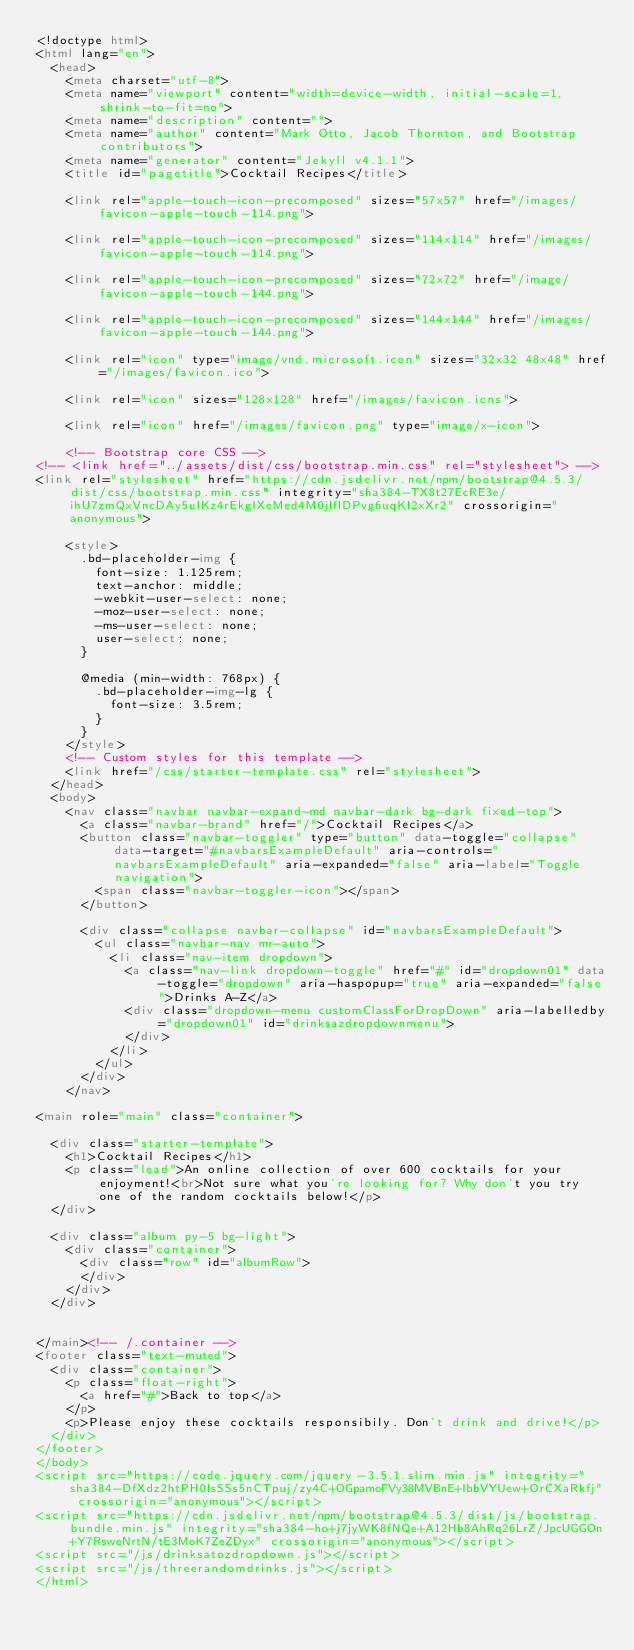<code> <loc_0><loc_0><loc_500><loc_500><_HTML_><!doctype html>
<html lang="en">
  <head>
    <meta charset="utf-8">
    <meta name="viewport" content="width=device-width, initial-scale=1, shrink-to-fit=no">
    <meta name="description" content="">
    <meta name="author" content="Mark Otto, Jacob Thornton, and Bootstrap contributors">
    <meta name="generator" content="Jekyll v4.1.1">
    <title id="pagetitle">Cocktail Recipes</title>
    
    <link rel="apple-touch-icon-precomposed" sizes="57x57" href="/images/favicon-apple-touch-114.png">

    <link rel="apple-touch-icon-precomposed" sizes="114x114" href="/images/favicon-apple-touch-114.png">

    <link rel="apple-touch-icon-precomposed" sizes="72x72" href="/image/favicon-apple-touch-144.png">

    <link rel="apple-touch-icon-precomposed" sizes="144x144" href="/images/favicon-apple-touch-144.png">

    <link rel="icon" type="image/vnd.microsoft.icon" sizes="32x32 48x48" href="/images/favicon.ico">

    <link rel="icon" sizes="128x128" href="/images/favicon.icns">

    <link rel="icon" href="/images/favicon.png" type="image/x-icon">

    <!-- Bootstrap core CSS -->
<!-- <link href="../assets/dist/css/bootstrap.min.css" rel="stylesheet"> -->
<link rel="stylesheet" href="https://cdn.jsdelivr.net/npm/bootstrap@4.5.3/dist/css/bootstrap.min.css" integrity="sha384-TX8t27EcRE3e/ihU7zmQxVncDAy5uIKz4rEkgIXeMed4M0jlfIDPvg6uqKI2xXr2" crossorigin="anonymous">

    <style>
      .bd-placeholder-img {
        font-size: 1.125rem;
        text-anchor: middle;
        -webkit-user-select: none;
        -moz-user-select: none;
        -ms-user-select: none;
        user-select: none;
      }

      @media (min-width: 768px) {
        .bd-placeholder-img-lg {
          font-size: 3.5rem;
        }
      }
    </style>
    <!-- Custom styles for this template -->
    <link href="/css/starter-template.css" rel="stylesheet">
  </head>
  <body>
    <nav class="navbar navbar-expand-md navbar-dark bg-dark fixed-top">
      <a class="navbar-brand" href="/">Cocktail Recipes</a>
      <button class="navbar-toggler" type="button" data-toggle="collapse" data-target="#navbarsExampleDefault" aria-controls="navbarsExampleDefault" aria-expanded="false" aria-label="Toggle navigation">
        <span class="navbar-toggler-icon"></span>
      </button>

      <div class="collapse navbar-collapse" id="navbarsExampleDefault">
        <ul class="navbar-nav mr-auto">
          <li class="nav-item dropdown">
            <a class="nav-link dropdown-toggle" href="#" id="dropdown01" data-toggle="dropdown" aria-haspopup="true" aria-expanded="false">Drinks A-Z</a>
            <div class="dropdown-menu customClassForDropDown" aria-labelledby="dropdown01" id="drinksazdropdownmenu">
            </div>
          </li>
        </ul>
      </div>
    </nav>

<main role="main" class="container">

  <div class="starter-template">
    <h1>Cocktail Recipes</h1>
    <p class="lead">An online collection of over 600 cocktails for your enjoyment!<br>Not sure what you're looking for? Why don't you try one of the random cocktails below!</p>
  </div>

  <div class="album py-5 bg-light">
    <div class="container">
      <div class="row" id="albumRow">
      </div>
    </div>
  </div>
  

</main><!-- /.container -->
<footer class="text-muted">
  <div class="container">
    <p class="float-right">
      <a href="#">Back to top</a>
    </p>
    <p>Please enjoy these cocktails responsibily. Don't drink and drive!</p>
  </div>
</footer>
</body>
<script src="https://code.jquery.com/jquery-3.5.1.slim.min.js" integrity="sha384-DfXdz2htPH0lsSSs5nCTpuj/zy4C+OGpamoFVy38MVBnE+IbbVYUew+OrCXaRkfj" crossorigin="anonymous"></script>
<script src="https://cdn.jsdelivr.net/npm/bootstrap@4.5.3/dist/js/bootstrap.bundle.min.js" integrity="sha384-ho+j7jyWK8fNQe+A12Hb8AhRq26LrZ/JpcUGGOn+Y7RsweNrtN/tE3MoK7ZeZDyx" crossorigin="anonymous"></script>
<script src="/js/drinksatozdropdown.js"></script>
<script src="/js/threerandomdrinks.js"></script>
</html></code> 